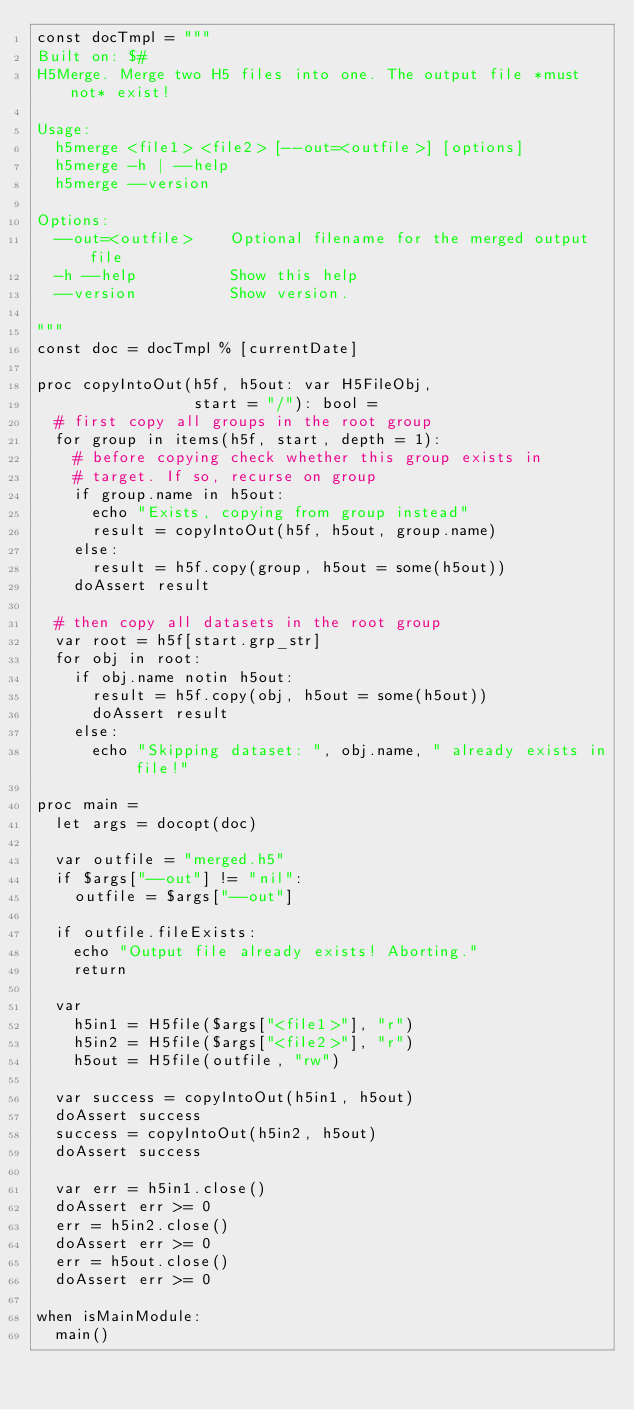<code> <loc_0><loc_0><loc_500><loc_500><_Nim_>const docTmpl = """
Built on: $#
H5Merge. Merge two H5 files into one. The output file *must not* exist!

Usage:
  h5merge <file1> <file2> [--out=<outfile>] [options]
  h5merge -h | --help
  h5merge --version

Options:
  --out=<outfile>    Optional filename for the merged output file
  -h --help          Show this help
  --version          Show version.

"""
const doc = docTmpl % [currentDate]

proc copyIntoOut(h5f, h5out: var H5FileObj,
                 start = "/"): bool =
  # first copy all groups in the root group
  for group in items(h5f, start, depth = 1):
    # before copying check whether this group exists in
    # target. If so, recurse on group
    if group.name in h5out:
      echo "Exists, copying from group instead"
      result = copyIntoOut(h5f, h5out, group.name)
    else:
      result = h5f.copy(group, h5out = some(h5out))
    doAssert result

  # then copy all datasets in the root group
  var root = h5f[start.grp_str]
  for obj in root:
    if obj.name notin h5out:
      result = h5f.copy(obj, h5out = some(h5out))
      doAssert result
    else:
      echo "Skipping dataset: ", obj.name, " already exists in file!"

proc main =
  let args = docopt(doc)

  var outfile = "merged.h5"
  if $args["--out"] != "nil":
    outfile = $args["--out"]

  if outfile.fileExists:
    echo "Output file already exists! Aborting."
    return

  var
    h5in1 = H5file($args["<file1>"], "r")
    h5in2 = H5file($args["<file2>"], "r")
    h5out = H5file(outfile, "rw")

  var success = copyIntoOut(h5in1, h5out)
  doAssert success
  success = copyIntoOut(h5in2, h5out)
  doAssert success

  var err = h5in1.close()
  doAssert err >= 0
  err = h5in2.close()
  doAssert err >= 0
  err = h5out.close()
  doAssert err >= 0

when isMainModule:
  main()
</code> 